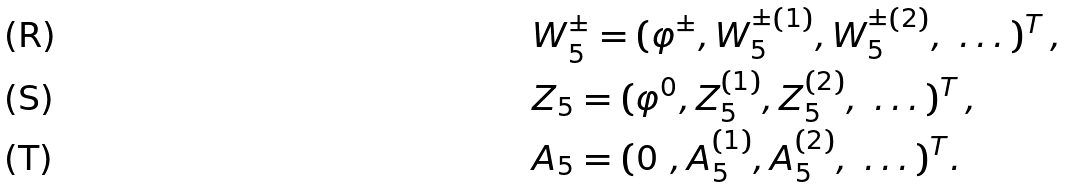<formula> <loc_0><loc_0><loc_500><loc_500>& W ^ { \pm } _ { 5 } = ( \varphi ^ { \pm } , W ^ { \pm ( 1 ) } _ { 5 } , W ^ { \pm ( 2 ) } _ { 5 } , \ \dots ) ^ { T } \, , \\ & Z _ { 5 } = ( \varphi ^ { 0 } , Z ^ { ( 1 ) } _ { 5 } , Z ^ { ( 2 ) } _ { 5 } , \ \dots ) ^ { T } \, , \\ & A _ { 5 } = ( 0 \ , A ^ { ( 1 ) } _ { 5 } , A ^ { ( 2 ) } _ { 5 } , \ \dots ) ^ { T } .</formula> 